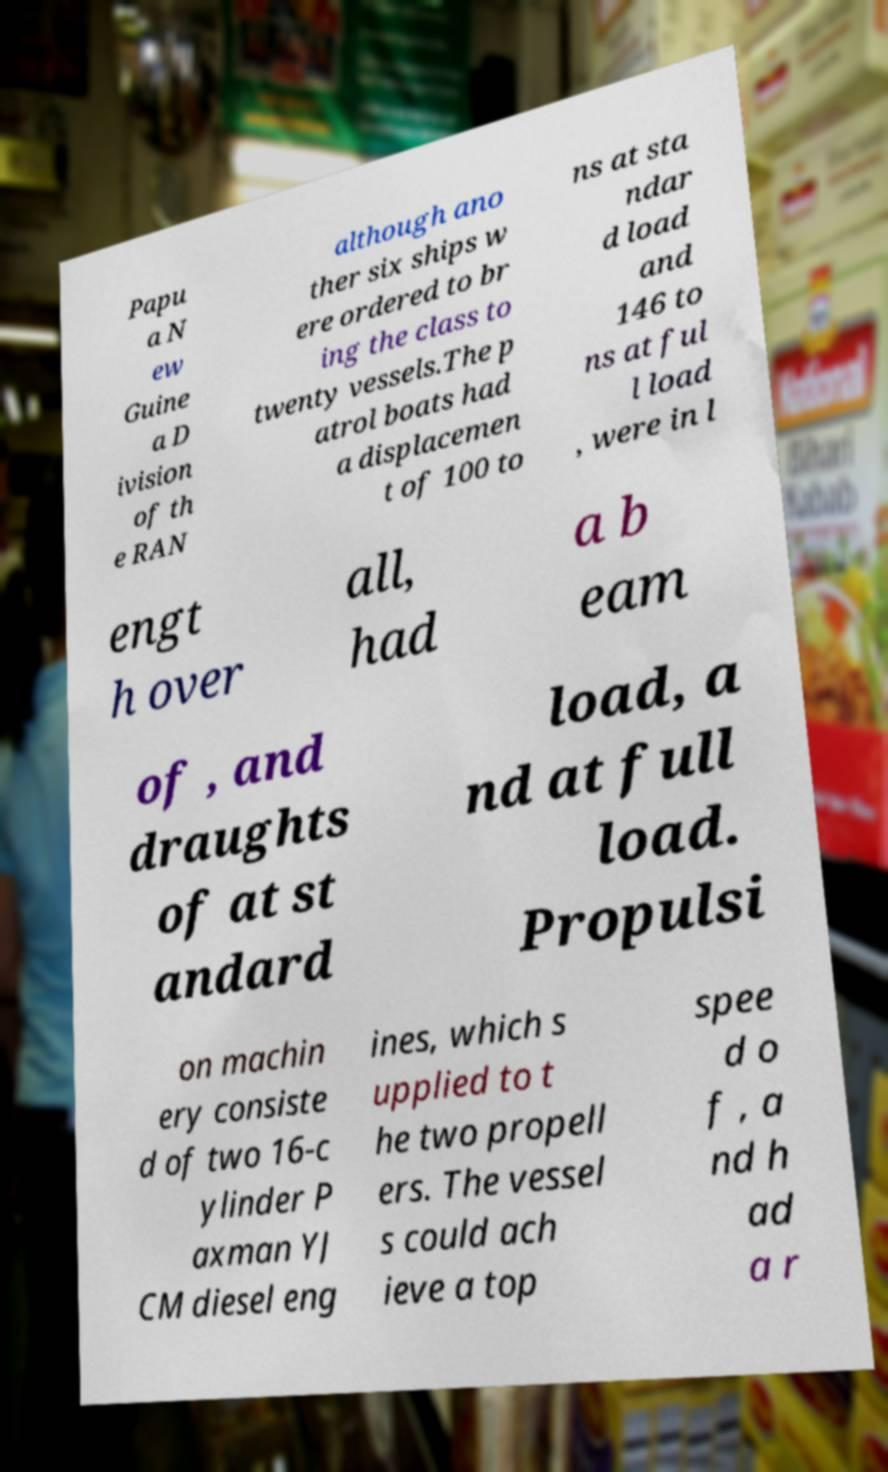For documentation purposes, I need the text within this image transcribed. Could you provide that? Papu a N ew Guine a D ivision of th e RAN although ano ther six ships w ere ordered to br ing the class to twenty vessels.The p atrol boats had a displacemen t of 100 to ns at sta ndar d load and 146 to ns at ful l load , were in l engt h over all, had a b eam of , and draughts of at st andard load, a nd at full load. Propulsi on machin ery consiste d of two 16-c ylinder P axman YJ CM diesel eng ines, which s upplied to t he two propell ers. The vessel s could ach ieve a top spee d o f , a nd h ad a r 